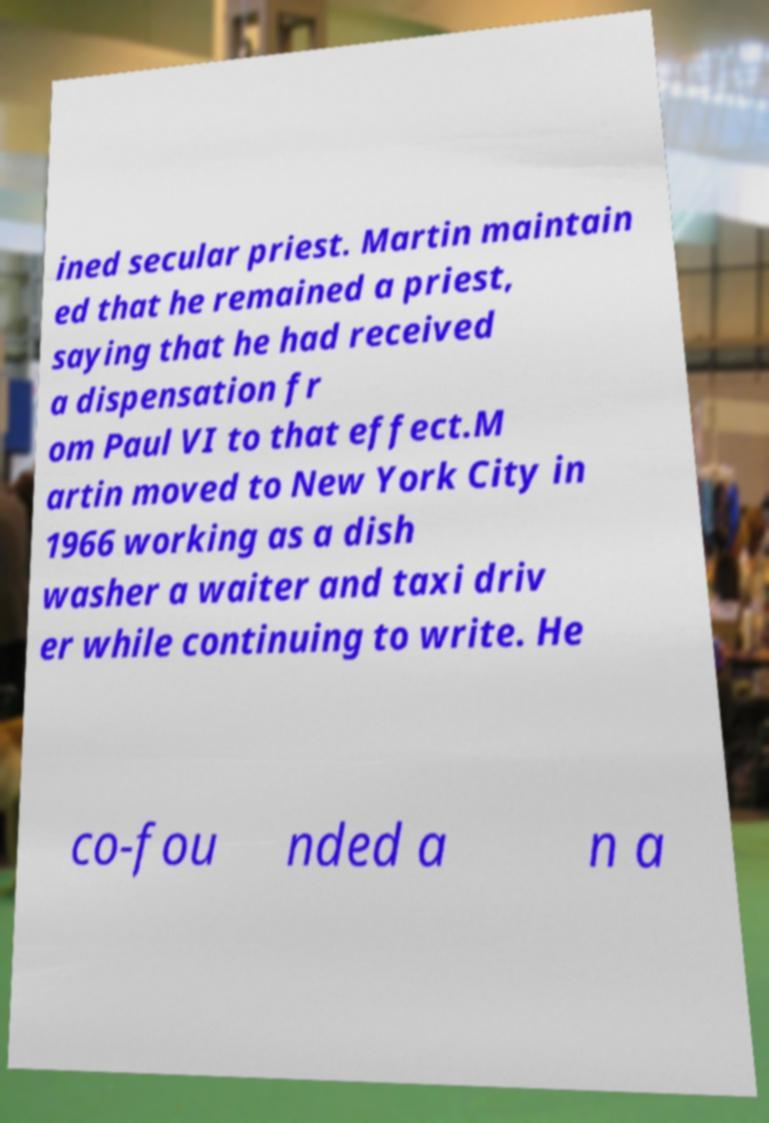What messages or text are displayed in this image? I need them in a readable, typed format. ined secular priest. Martin maintain ed that he remained a priest, saying that he had received a dispensation fr om Paul VI to that effect.M artin moved to New York City in 1966 working as a dish washer a waiter and taxi driv er while continuing to write. He co-fou nded a n a 